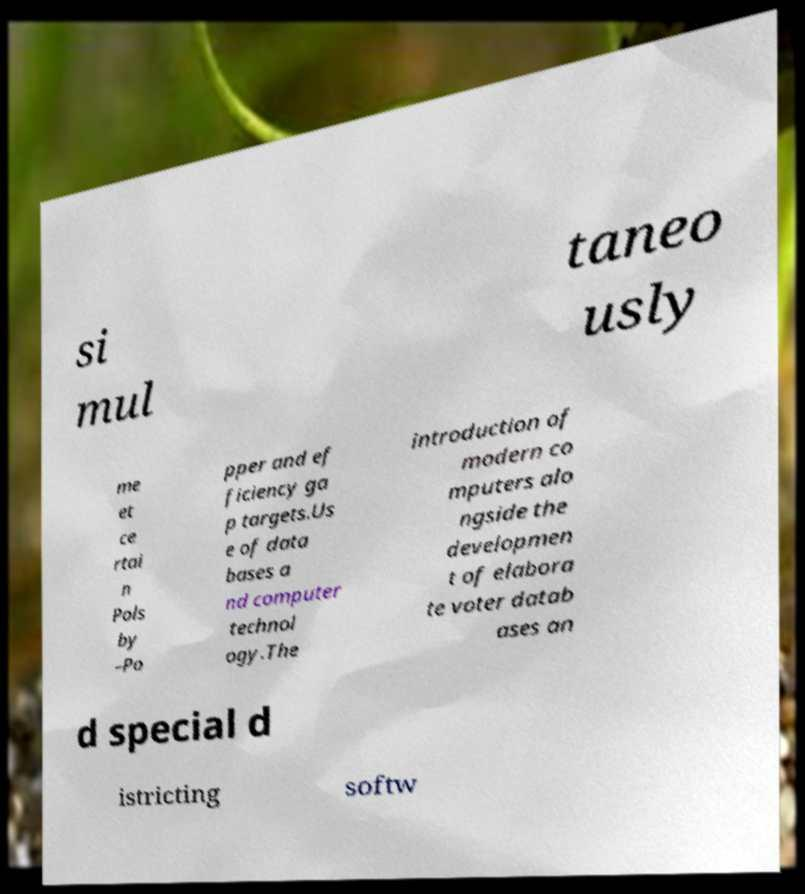Could you extract and type out the text from this image? si mul taneo usly me et ce rtai n Pols by –Po pper and ef ficiency ga p targets.Us e of data bases a nd computer technol ogy.The introduction of modern co mputers alo ngside the developmen t of elabora te voter datab ases an d special d istricting softw 